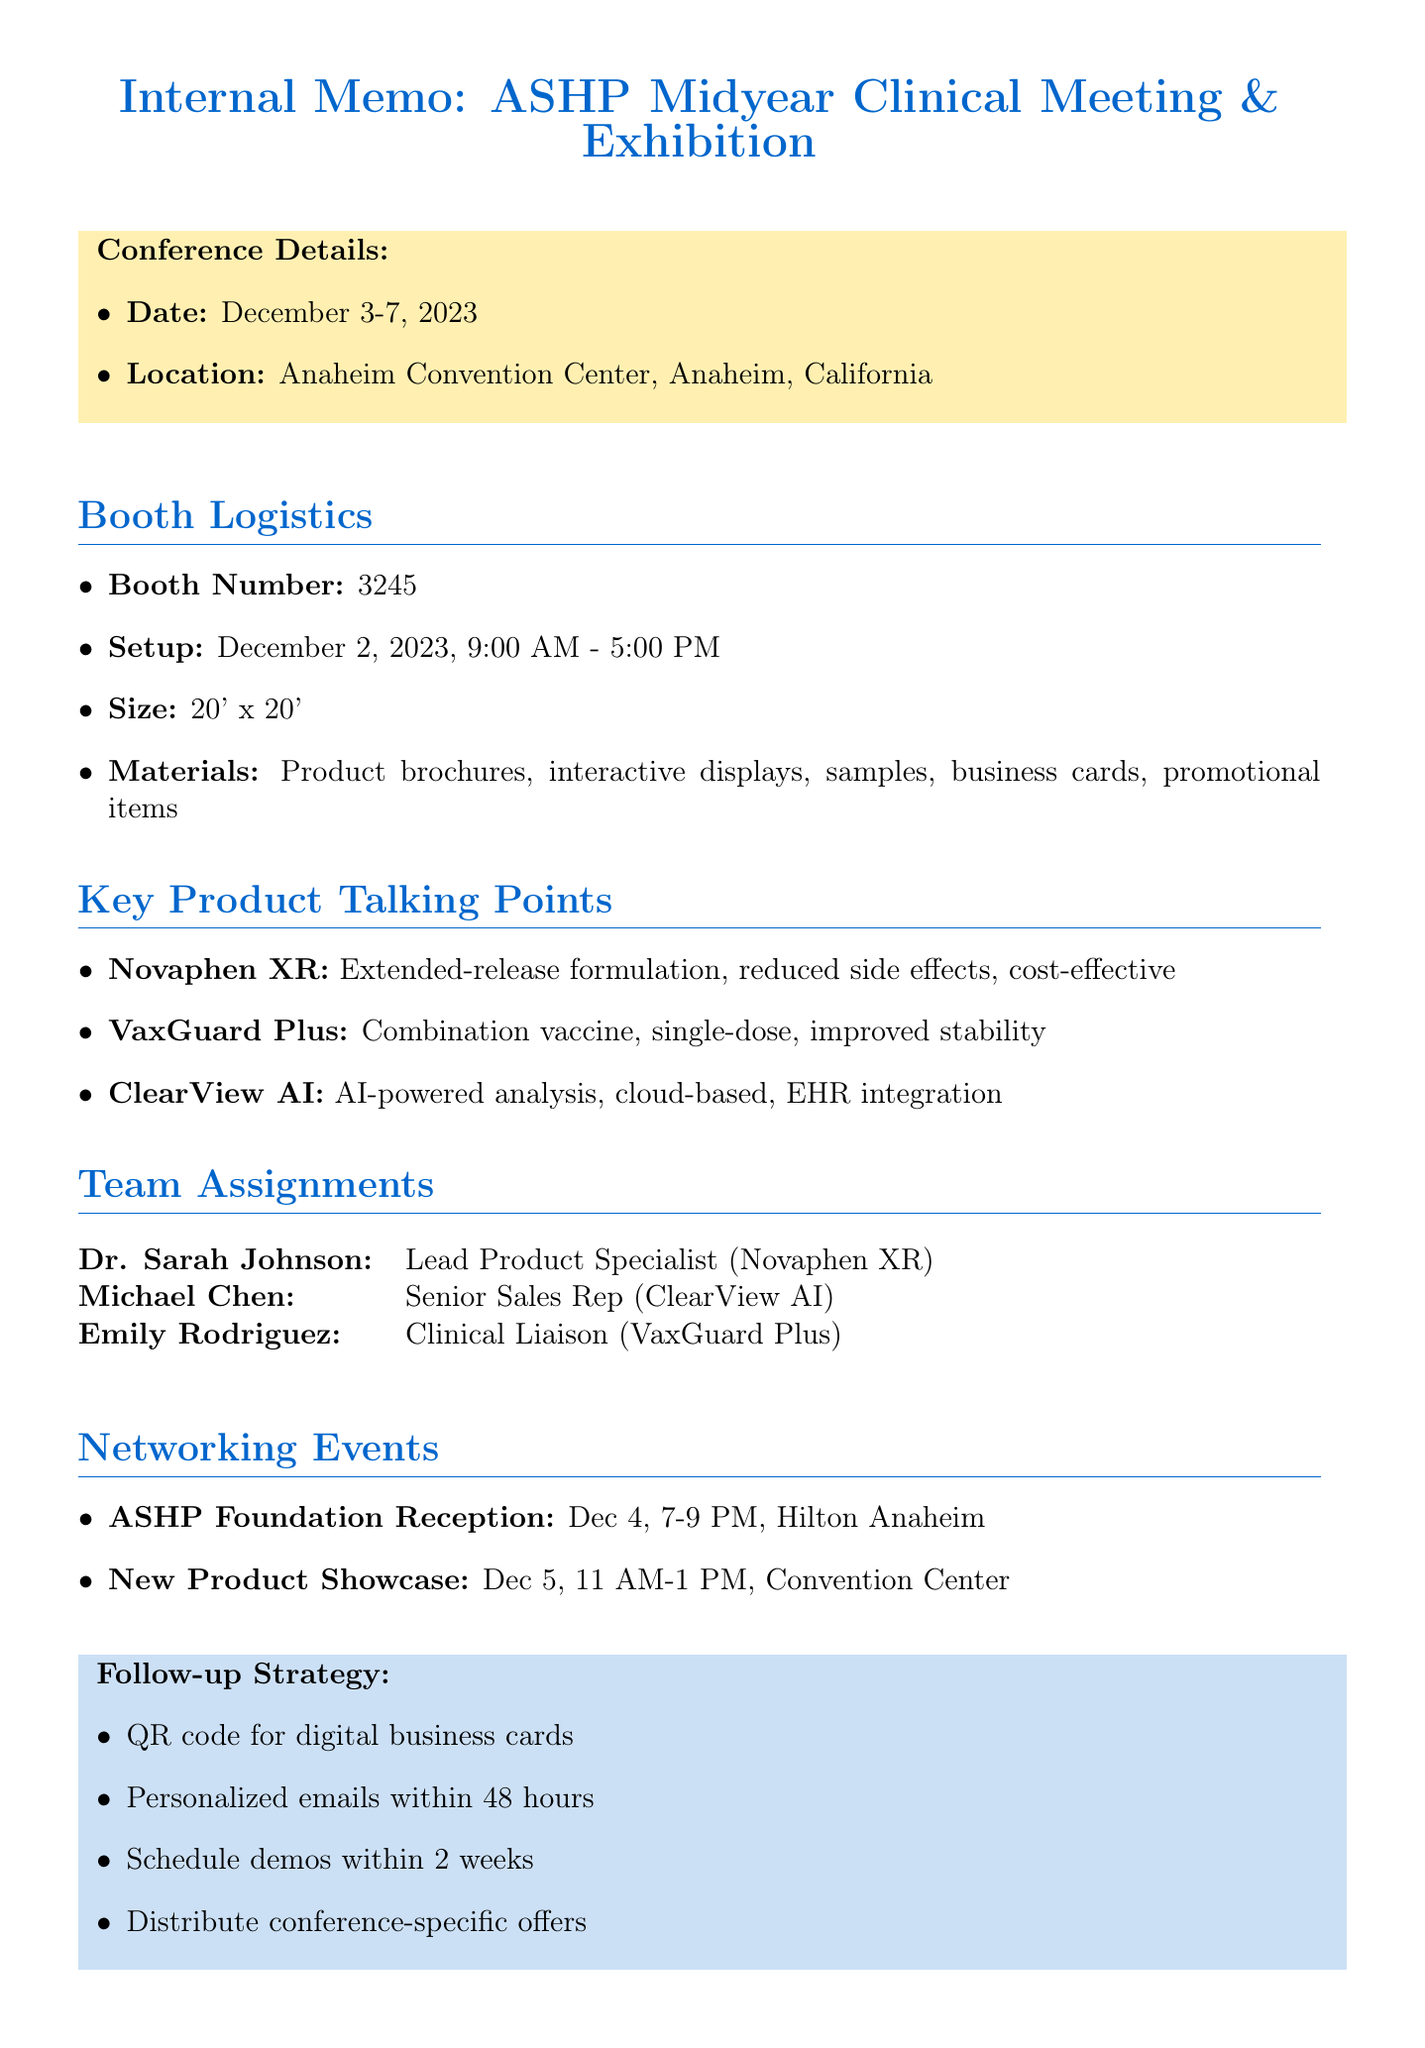What is the name of the conference? The document mentions the conference name as the American Society of Health-System Pharmacists (ASHP) Midyear Clinical Meeting & Exhibition.
Answer: American Society of Health-System Pharmacists (ASHP) Midyear Clinical Meeting & Exhibition What are the setup hours for the booth? The document specifies that the booth setup time is from 9:00 AM to 5:00 PM on December 2, 2023.
Answer: 9:00 AM - 5:00 PM What is the booth number? The document lists the booth number as 3245.
Answer: 3245 Who is responsible for presenting VaxGuard Plus clinical data? According to the document, Emily Rodriguez is the Clinical Liaison and is responsible for presenting VaxGuard Plus clinical data.
Answer: Emily Rodriguez What key advantage does Novaphen XR offer? The document highlights that Novaphen XR has an extended-release formulation for better patient compliance.
Answer: Extended-release formulation for better patient compliance What is the date and location of the ASHP Foundation Reception? The document states that the ASHP Foundation Reception is on December 4, 2023, at the Hilton Anaheim, Pacific Ballroom.
Answer: December 4, 2023, Hilton Anaheim, Pacific Ballroom What follow-up action should be taken within 48 hours? The document outlines that personalized emails should be sent within 48 hours following the conference.
Answer: Send personalized emails What is the size of the booth? The document specifies the booth size as 20' x 20'.
Answer: 20' x 20' What is the method for lead collection mentioned in the memo? The document mentions using a QR code scan for digital business cards as the lead collection method.
Answer: QR code scan for digital business cards 